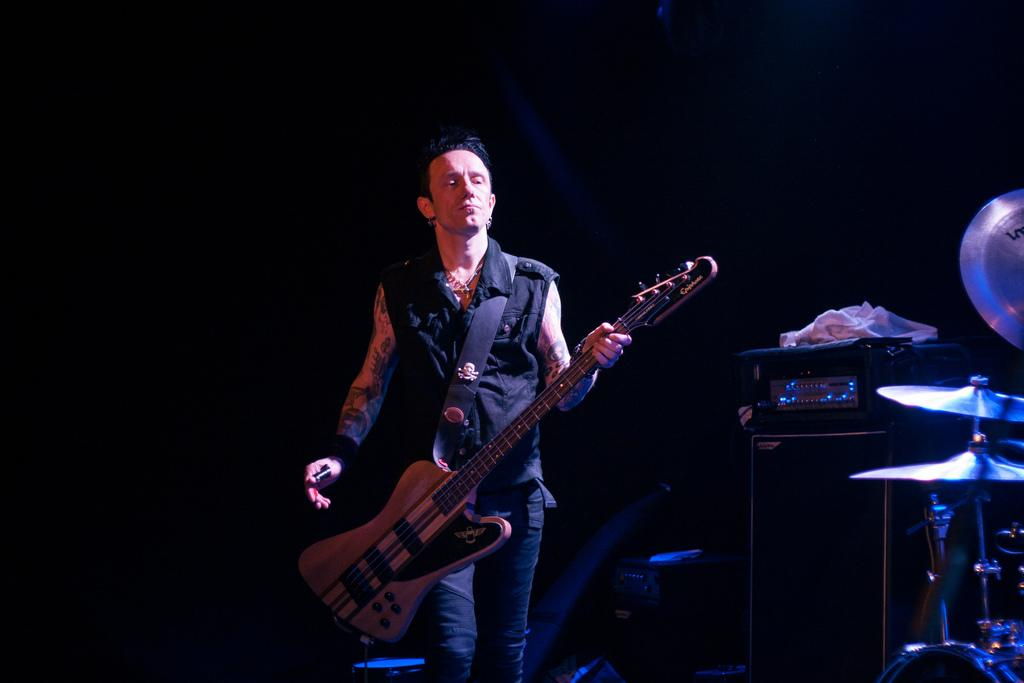What is the man in the image holding? The man is holding a guitar. What is the man's posture in the image? The man is standing. What can be seen on the right side of the image? There are musical instruments on the right side of the image. What device is present in the image for amplifying sound? There is a speaker in the image. What type of equipment is visible in the image? There is an equipment in the image. How does the man kick the basketball in the image? There is no basketball present in the image, so the man cannot kick a basketball. 